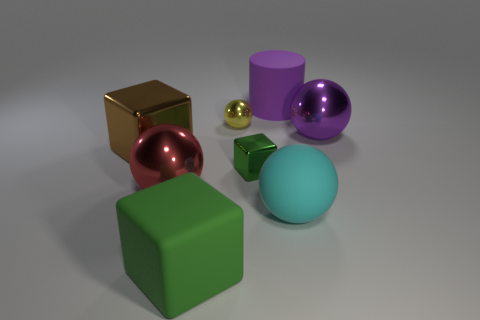Subtract all purple spheres. How many spheres are left? 3 Add 2 large purple cylinders. How many objects exist? 10 Subtract all cubes. How many objects are left? 5 Add 3 tiny balls. How many tiny balls are left? 4 Add 6 large rubber objects. How many large rubber objects exist? 9 Subtract all brown blocks. How many blocks are left? 2 Subtract 0 green balls. How many objects are left? 8 Subtract 1 cylinders. How many cylinders are left? 0 Subtract all brown cylinders. Subtract all purple blocks. How many cylinders are left? 1 Subtract all purple cubes. How many green cylinders are left? 0 